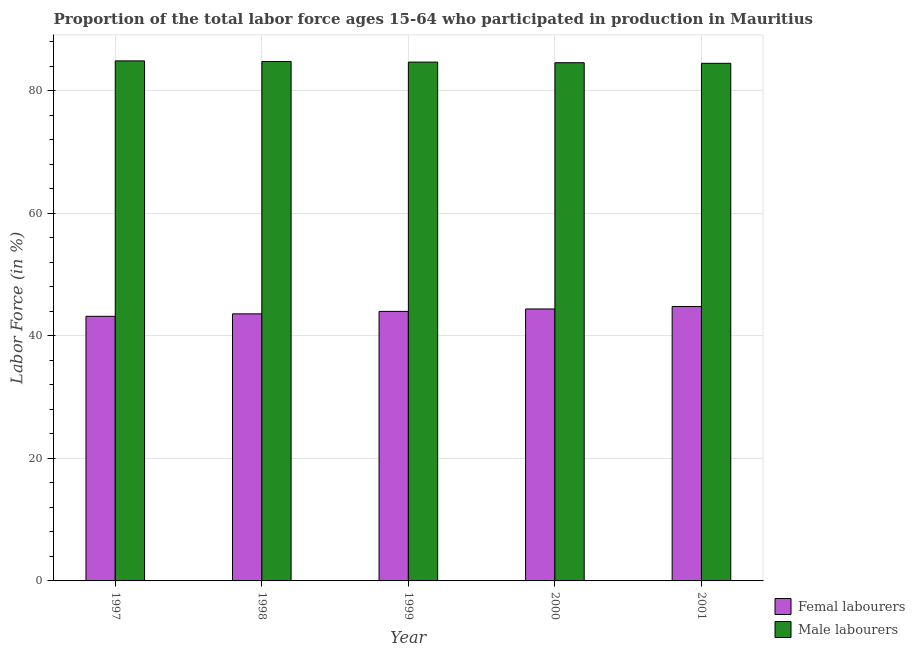How many groups of bars are there?
Ensure brevity in your answer.  5. Are the number of bars on each tick of the X-axis equal?
Provide a short and direct response. Yes. How many bars are there on the 2nd tick from the left?
Your answer should be compact. 2. How many bars are there on the 4th tick from the right?
Offer a terse response. 2. In how many cases, is the number of bars for a given year not equal to the number of legend labels?
Provide a succinct answer. 0. Across all years, what is the maximum percentage of female labor force?
Offer a terse response. 44.8. Across all years, what is the minimum percentage of male labour force?
Provide a short and direct response. 84.5. What is the total percentage of female labor force in the graph?
Your answer should be compact. 220. What is the difference between the percentage of female labor force in 1997 and that in 1999?
Your response must be concise. -0.8. What is the difference between the percentage of female labor force in 2001 and the percentage of male labour force in 1999?
Your answer should be compact. 0.8. What is the average percentage of male labour force per year?
Provide a short and direct response. 84.7. In the year 1999, what is the difference between the percentage of male labour force and percentage of female labor force?
Provide a short and direct response. 0. What is the ratio of the percentage of female labor force in 1997 to that in 1999?
Make the answer very short. 0.98. What is the difference between the highest and the second highest percentage of female labor force?
Your answer should be compact. 0.4. What is the difference between the highest and the lowest percentage of male labour force?
Provide a short and direct response. 0.4. In how many years, is the percentage of male labour force greater than the average percentage of male labour force taken over all years?
Give a very brief answer. 2. Is the sum of the percentage of female labor force in 1997 and 2001 greater than the maximum percentage of male labour force across all years?
Your answer should be compact. Yes. What does the 1st bar from the left in 2000 represents?
Offer a terse response. Femal labourers. What does the 1st bar from the right in 1998 represents?
Offer a terse response. Male labourers. How many bars are there?
Provide a short and direct response. 10. What is the difference between two consecutive major ticks on the Y-axis?
Provide a short and direct response. 20. Does the graph contain grids?
Provide a succinct answer. Yes. Where does the legend appear in the graph?
Provide a short and direct response. Bottom right. How many legend labels are there?
Ensure brevity in your answer.  2. How are the legend labels stacked?
Your response must be concise. Vertical. What is the title of the graph?
Offer a terse response. Proportion of the total labor force ages 15-64 who participated in production in Mauritius. What is the label or title of the X-axis?
Provide a short and direct response. Year. What is the Labor Force (in %) in Femal labourers in 1997?
Your answer should be very brief. 43.2. What is the Labor Force (in %) of Male labourers in 1997?
Your answer should be compact. 84.9. What is the Labor Force (in %) of Femal labourers in 1998?
Provide a short and direct response. 43.6. What is the Labor Force (in %) in Male labourers in 1998?
Give a very brief answer. 84.8. What is the Labor Force (in %) of Femal labourers in 1999?
Ensure brevity in your answer.  44. What is the Labor Force (in %) in Male labourers in 1999?
Provide a short and direct response. 84.7. What is the Labor Force (in %) in Femal labourers in 2000?
Make the answer very short. 44.4. What is the Labor Force (in %) of Male labourers in 2000?
Give a very brief answer. 84.6. What is the Labor Force (in %) of Femal labourers in 2001?
Offer a very short reply. 44.8. What is the Labor Force (in %) of Male labourers in 2001?
Your answer should be compact. 84.5. Across all years, what is the maximum Labor Force (in %) in Femal labourers?
Your response must be concise. 44.8. Across all years, what is the maximum Labor Force (in %) of Male labourers?
Offer a very short reply. 84.9. Across all years, what is the minimum Labor Force (in %) of Femal labourers?
Provide a succinct answer. 43.2. Across all years, what is the minimum Labor Force (in %) of Male labourers?
Your response must be concise. 84.5. What is the total Labor Force (in %) of Femal labourers in the graph?
Provide a succinct answer. 220. What is the total Labor Force (in %) in Male labourers in the graph?
Give a very brief answer. 423.5. What is the difference between the Labor Force (in %) of Male labourers in 1997 and that in 1999?
Offer a terse response. 0.2. What is the difference between the Labor Force (in %) of Femal labourers in 1997 and that in 2000?
Keep it short and to the point. -1.2. What is the difference between the Labor Force (in %) of Male labourers in 1997 and that in 2000?
Offer a terse response. 0.3. What is the difference between the Labor Force (in %) in Femal labourers in 1997 and that in 2001?
Give a very brief answer. -1.6. What is the difference between the Labor Force (in %) of Femal labourers in 1998 and that in 2000?
Make the answer very short. -0.8. What is the difference between the Labor Force (in %) of Male labourers in 1998 and that in 2000?
Offer a terse response. 0.2. What is the difference between the Labor Force (in %) of Femal labourers in 1998 and that in 2001?
Your answer should be compact. -1.2. What is the difference between the Labor Force (in %) of Femal labourers in 1999 and that in 2000?
Provide a succinct answer. -0.4. What is the difference between the Labor Force (in %) in Femal labourers in 1999 and that in 2001?
Ensure brevity in your answer.  -0.8. What is the difference between the Labor Force (in %) in Femal labourers in 2000 and that in 2001?
Ensure brevity in your answer.  -0.4. What is the difference between the Labor Force (in %) in Male labourers in 2000 and that in 2001?
Your answer should be very brief. 0.1. What is the difference between the Labor Force (in %) of Femal labourers in 1997 and the Labor Force (in %) of Male labourers in 1998?
Give a very brief answer. -41.6. What is the difference between the Labor Force (in %) of Femal labourers in 1997 and the Labor Force (in %) of Male labourers in 1999?
Give a very brief answer. -41.5. What is the difference between the Labor Force (in %) in Femal labourers in 1997 and the Labor Force (in %) in Male labourers in 2000?
Your answer should be compact. -41.4. What is the difference between the Labor Force (in %) in Femal labourers in 1997 and the Labor Force (in %) in Male labourers in 2001?
Your response must be concise. -41.3. What is the difference between the Labor Force (in %) in Femal labourers in 1998 and the Labor Force (in %) in Male labourers in 1999?
Keep it short and to the point. -41.1. What is the difference between the Labor Force (in %) of Femal labourers in 1998 and the Labor Force (in %) of Male labourers in 2000?
Provide a short and direct response. -41. What is the difference between the Labor Force (in %) of Femal labourers in 1998 and the Labor Force (in %) of Male labourers in 2001?
Keep it short and to the point. -40.9. What is the difference between the Labor Force (in %) of Femal labourers in 1999 and the Labor Force (in %) of Male labourers in 2000?
Your answer should be very brief. -40.6. What is the difference between the Labor Force (in %) of Femal labourers in 1999 and the Labor Force (in %) of Male labourers in 2001?
Offer a terse response. -40.5. What is the difference between the Labor Force (in %) of Femal labourers in 2000 and the Labor Force (in %) of Male labourers in 2001?
Keep it short and to the point. -40.1. What is the average Labor Force (in %) in Femal labourers per year?
Offer a very short reply. 44. What is the average Labor Force (in %) of Male labourers per year?
Keep it short and to the point. 84.7. In the year 1997, what is the difference between the Labor Force (in %) of Femal labourers and Labor Force (in %) of Male labourers?
Give a very brief answer. -41.7. In the year 1998, what is the difference between the Labor Force (in %) in Femal labourers and Labor Force (in %) in Male labourers?
Give a very brief answer. -41.2. In the year 1999, what is the difference between the Labor Force (in %) of Femal labourers and Labor Force (in %) of Male labourers?
Give a very brief answer. -40.7. In the year 2000, what is the difference between the Labor Force (in %) of Femal labourers and Labor Force (in %) of Male labourers?
Offer a very short reply. -40.2. In the year 2001, what is the difference between the Labor Force (in %) in Femal labourers and Labor Force (in %) in Male labourers?
Make the answer very short. -39.7. What is the ratio of the Labor Force (in %) of Femal labourers in 1997 to that in 1999?
Your answer should be very brief. 0.98. What is the ratio of the Labor Force (in %) in Male labourers in 1997 to that in 1999?
Make the answer very short. 1. What is the ratio of the Labor Force (in %) of Male labourers in 1997 to that in 2000?
Your answer should be very brief. 1. What is the ratio of the Labor Force (in %) in Femal labourers in 1997 to that in 2001?
Your answer should be compact. 0.96. What is the ratio of the Labor Force (in %) of Male labourers in 1997 to that in 2001?
Your response must be concise. 1. What is the ratio of the Labor Force (in %) of Femal labourers in 1998 to that in 1999?
Your response must be concise. 0.99. What is the ratio of the Labor Force (in %) in Femal labourers in 1998 to that in 2000?
Your response must be concise. 0.98. What is the ratio of the Labor Force (in %) of Male labourers in 1998 to that in 2000?
Keep it short and to the point. 1. What is the ratio of the Labor Force (in %) in Femal labourers in 1998 to that in 2001?
Ensure brevity in your answer.  0.97. What is the ratio of the Labor Force (in %) of Femal labourers in 1999 to that in 2000?
Provide a short and direct response. 0.99. What is the ratio of the Labor Force (in %) of Femal labourers in 1999 to that in 2001?
Your response must be concise. 0.98. What is the ratio of the Labor Force (in %) in Male labourers in 1999 to that in 2001?
Offer a very short reply. 1. What is the ratio of the Labor Force (in %) of Male labourers in 2000 to that in 2001?
Your answer should be very brief. 1. What is the difference between the highest and the second highest Labor Force (in %) in Male labourers?
Offer a very short reply. 0.1. 